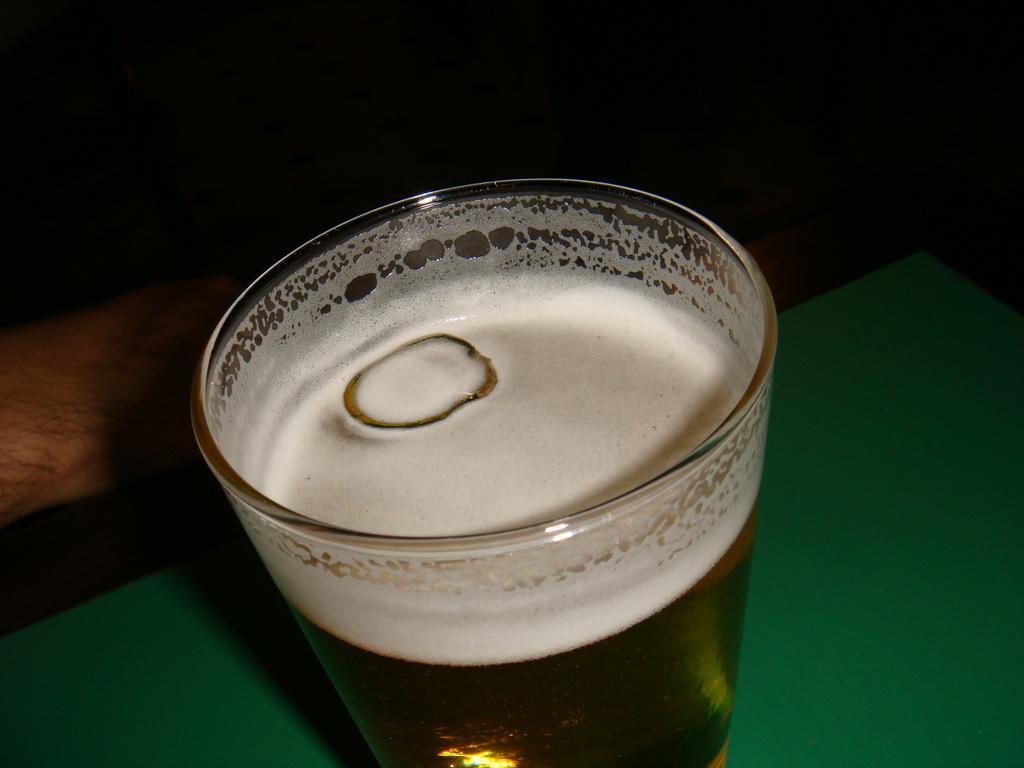Describe this image in one or two sentences. In this picture a glass with a drink in it is highlighted. This is a ice cube, near to the glass partial part of human's hand is visible. This is a green colour mat. 